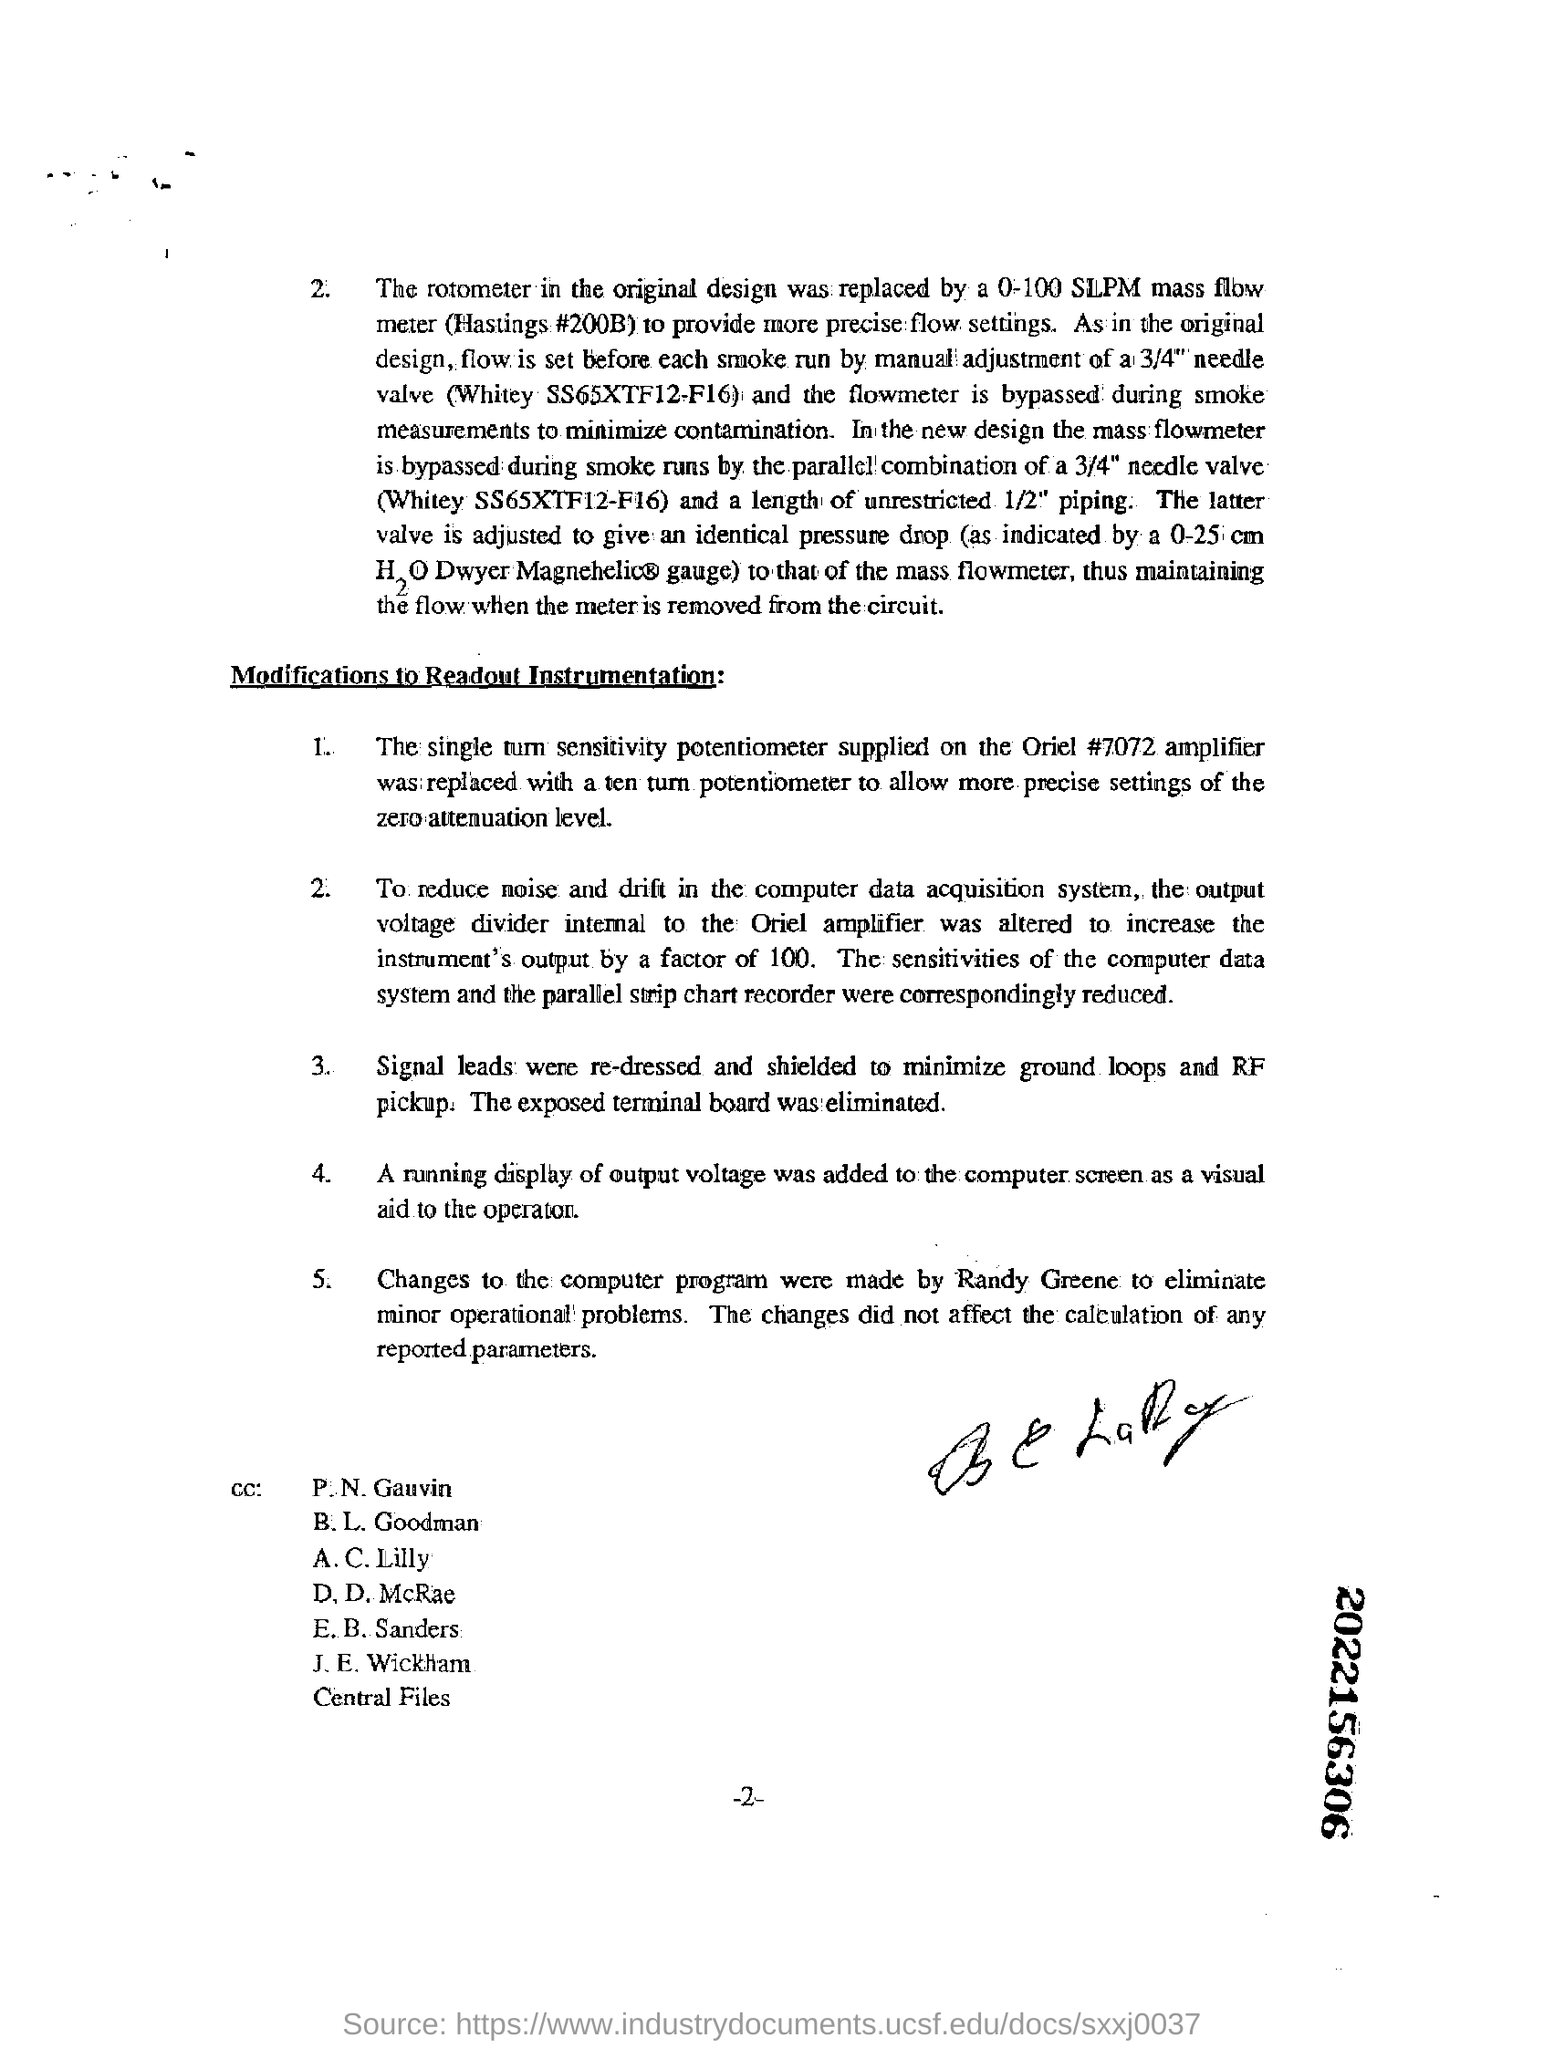How many points are there in modifications to readout instrumentation
Your response must be concise. 5. 